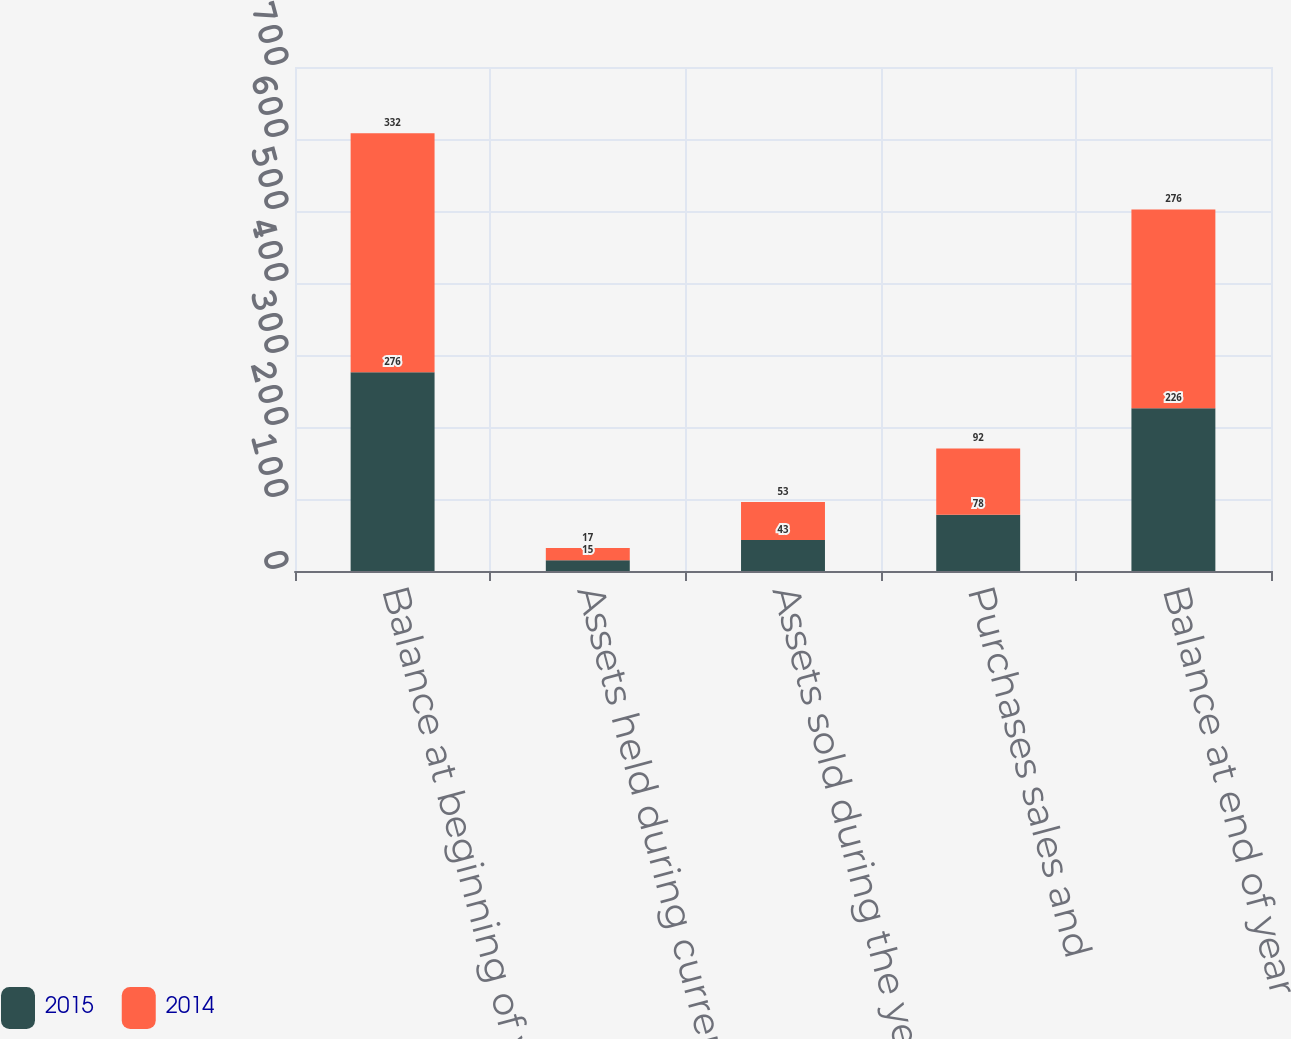<chart> <loc_0><loc_0><loc_500><loc_500><stacked_bar_chart><ecel><fcel>Balance at beginning of year<fcel>Assets held during current<fcel>Assets sold during the year<fcel>Purchases sales and<fcel>Balance at end of year<nl><fcel>2015<fcel>276<fcel>15<fcel>43<fcel>78<fcel>226<nl><fcel>2014<fcel>332<fcel>17<fcel>53<fcel>92<fcel>276<nl></chart> 